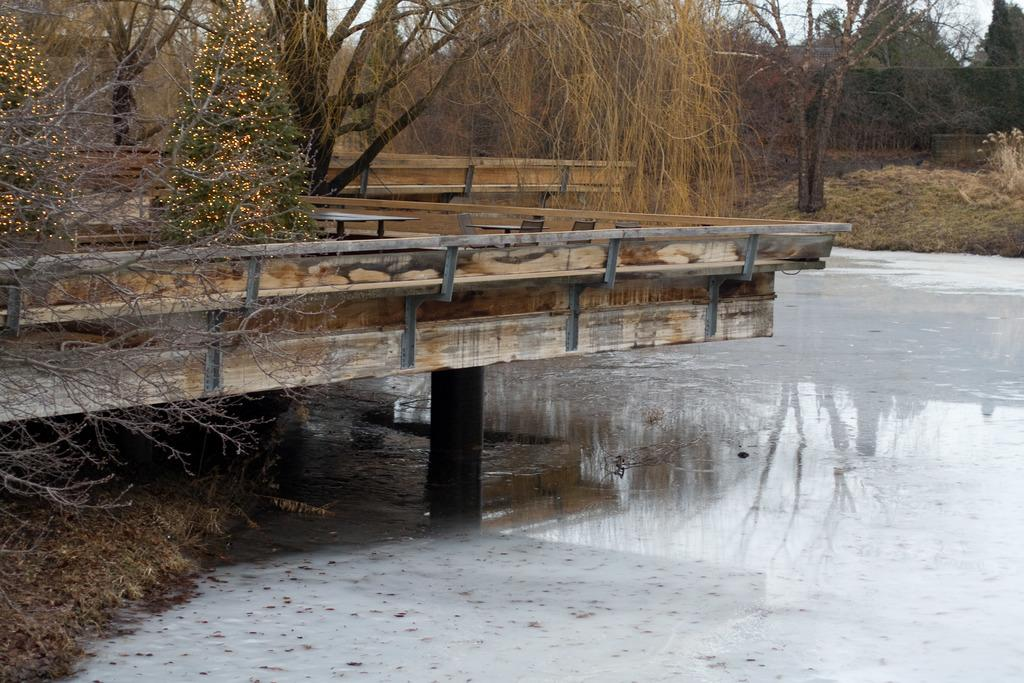What type of structure is present in the image? There is a wooden bridge in the image. What is the bridge situated over? The bridge is over water. What type of vegetation can be seen in the image? There are trees and grass in the image. What part of the natural environment is visible in the image? The sky is visible in the image. What type of pencil can be seen in the image? There is no pencil present in the image. 